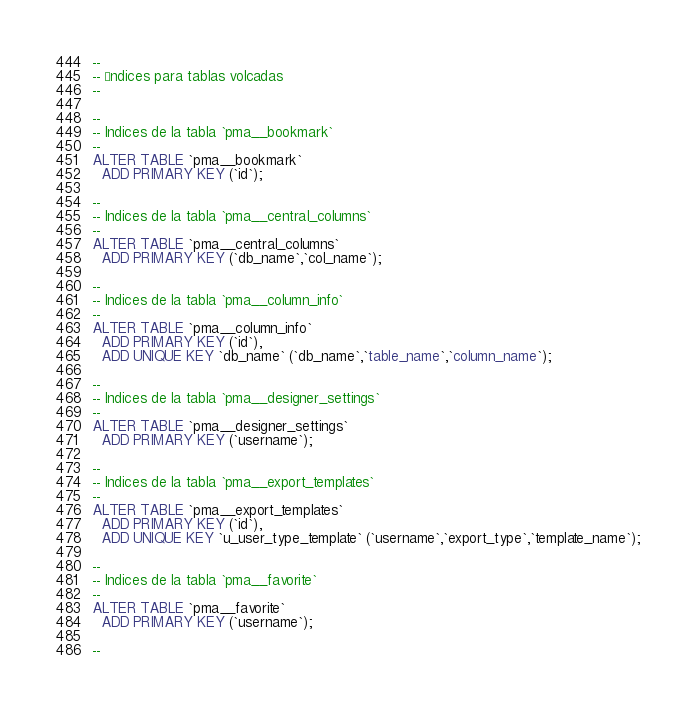<code> <loc_0><loc_0><loc_500><loc_500><_SQL_>
--
-- Índices para tablas volcadas
--

--
-- Indices de la tabla `pma__bookmark`
--
ALTER TABLE `pma__bookmark`
  ADD PRIMARY KEY (`id`);

--
-- Indices de la tabla `pma__central_columns`
--
ALTER TABLE `pma__central_columns`
  ADD PRIMARY KEY (`db_name`,`col_name`);

--
-- Indices de la tabla `pma__column_info`
--
ALTER TABLE `pma__column_info`
  ADD PRIMARY KEY (`id`),
  ADD UNIQUE KEY `db_name` (`db_name`,`table_name`,`column_name`);

--
-- Indices de la tabla `pma__designer_settings`
--
ALTER TABLE `pma__designer_settings`
  ADD PRIMARY KEY (`username`);

--
-- Indices de la tabla `pma__export_templates`
--
ALTER TABLE `pma__export_templates`
  ADD PRIMARY KEY (`id`),
  ADD UNIQUE KEY `u_user_type_template` (`username`,`export_type`,`template_name`);

--
-- Indices de la tabla `pma__favorite`
--
ALTER TABLE `pma__favorite`
  ADD PRIMARY KEY (`username`);

--</code> 